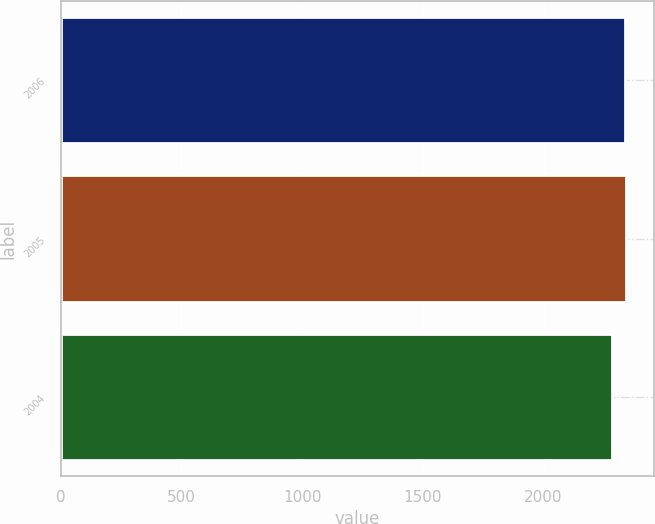<chart> <loc_0><loc_0><loc_500><loc_500><bar_chart><fcel>2006<fcel>2005<fcel>2004<nl><fcel>2336<fcel>2341.2<fcel>2284<nl></chart> 